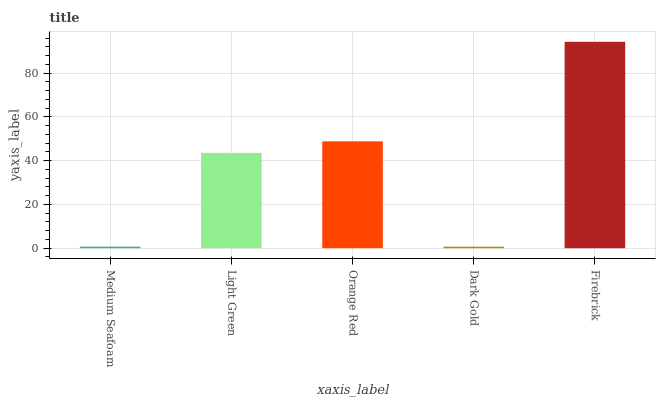Is Dark Gold the minimum?
Answer yes or no. Yes. Is Firebrick the maximum?
Answer yes or no. Yes. Is Light Green the minimum?
Answer yes or no. No. Is Light Green the maximum?
Answer yes or no. No. Is Light Green greater than Medium Seafoam?
Answer yes or no. Yes. Is Medium Seafoam less than Light Green?
Answer yes or no. Yes. Is Medium Seafoam greater than Light Green?
Answer yes or no. No. Is Light Green less than Medium Seafoam?
Answer yes or no. No. Is Light Green the high median?
Answer yes or no. Yes. Is Light Green the low median?
Answer yes or no. Yes. Is Medium Seafoam the high median?
Answer yes or no. No. Is Firebrick the low median?
Answer yes or no. No. 